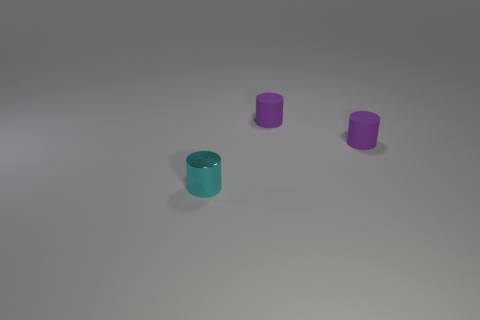What is the color of the shiny object? cyan 